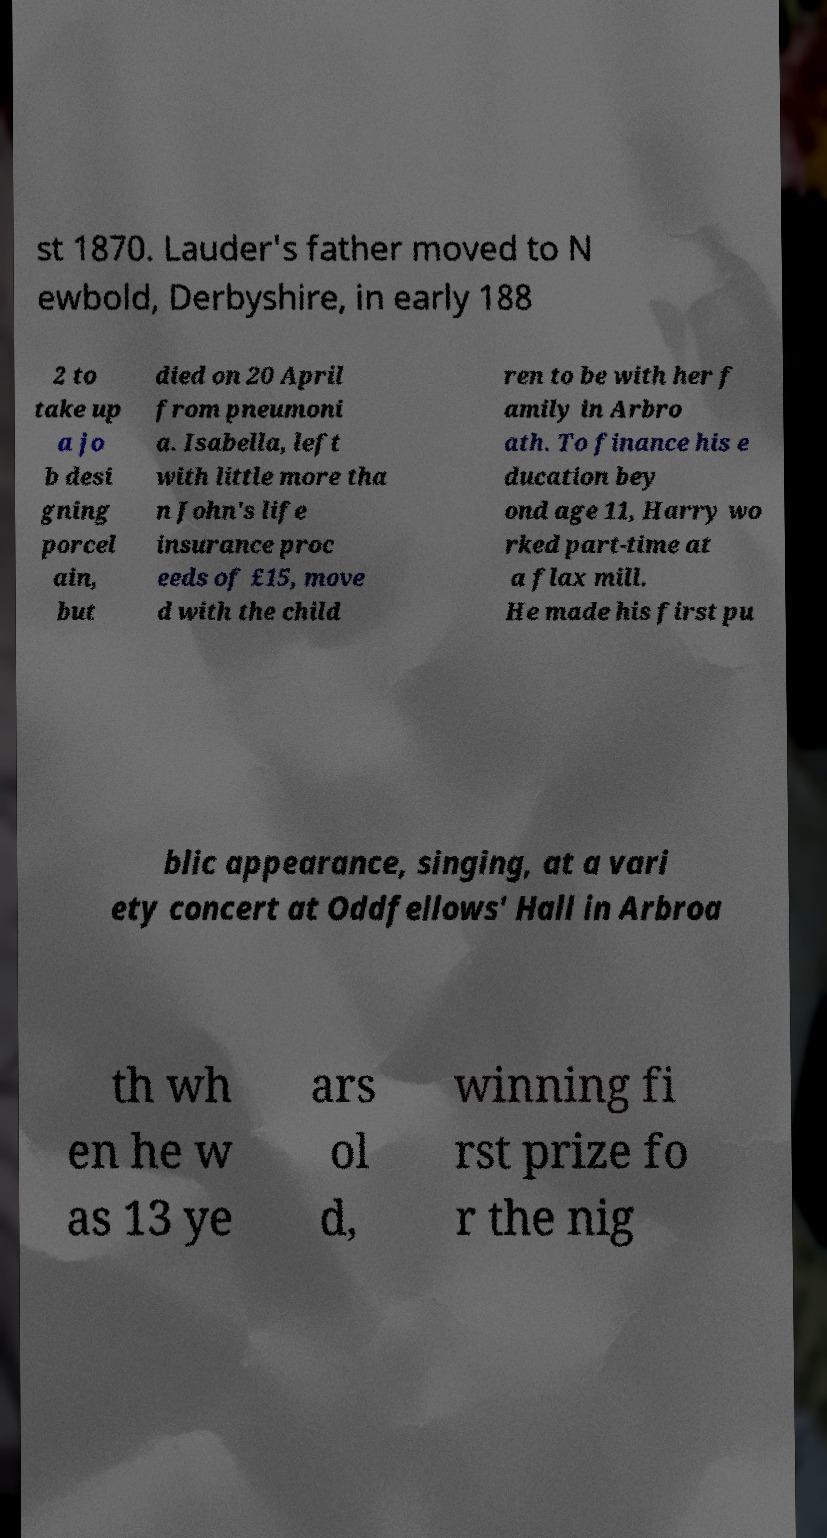Can you read and provide the text displayed in the image?This photo seems to have some interesting text. Can you extract and type it out for me? st 1870. Lauder's father moved to N ewbold, Derbyshire, in early 188 2 to take up a jo b desi gning porcel ain, but died on 20 April from pneumoni a. Isabella, left with little more tha n John's life insurance proc eeds of £15, move d with the child ren to be with her f amily in Arbro ath. To finance his e ducation bey ond age 11, Harry wo rked part-time at a flax mill. He made his first pu blic appearance, singing, at a vari ety concert at Oddfellows' Hall in Arbroa th wh en he w as 13 ye ars ol d, winning fi rst prize fo r the nig 